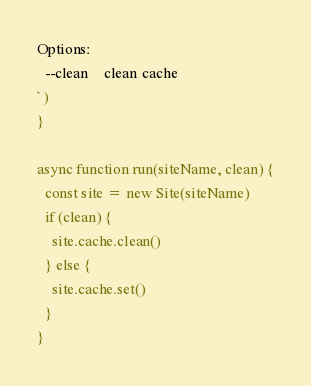<code> <loc_0><loc_0><loc_500><loc_500><_JavaScript_>Options:
  --clean    clean cache
`)
}

async function run(siteName, clean) {
  const site = new Site(siteName)
  if (clean) {
    site.cache.clean()
  } else {
    site.cache.set()
  }
}
</code> 